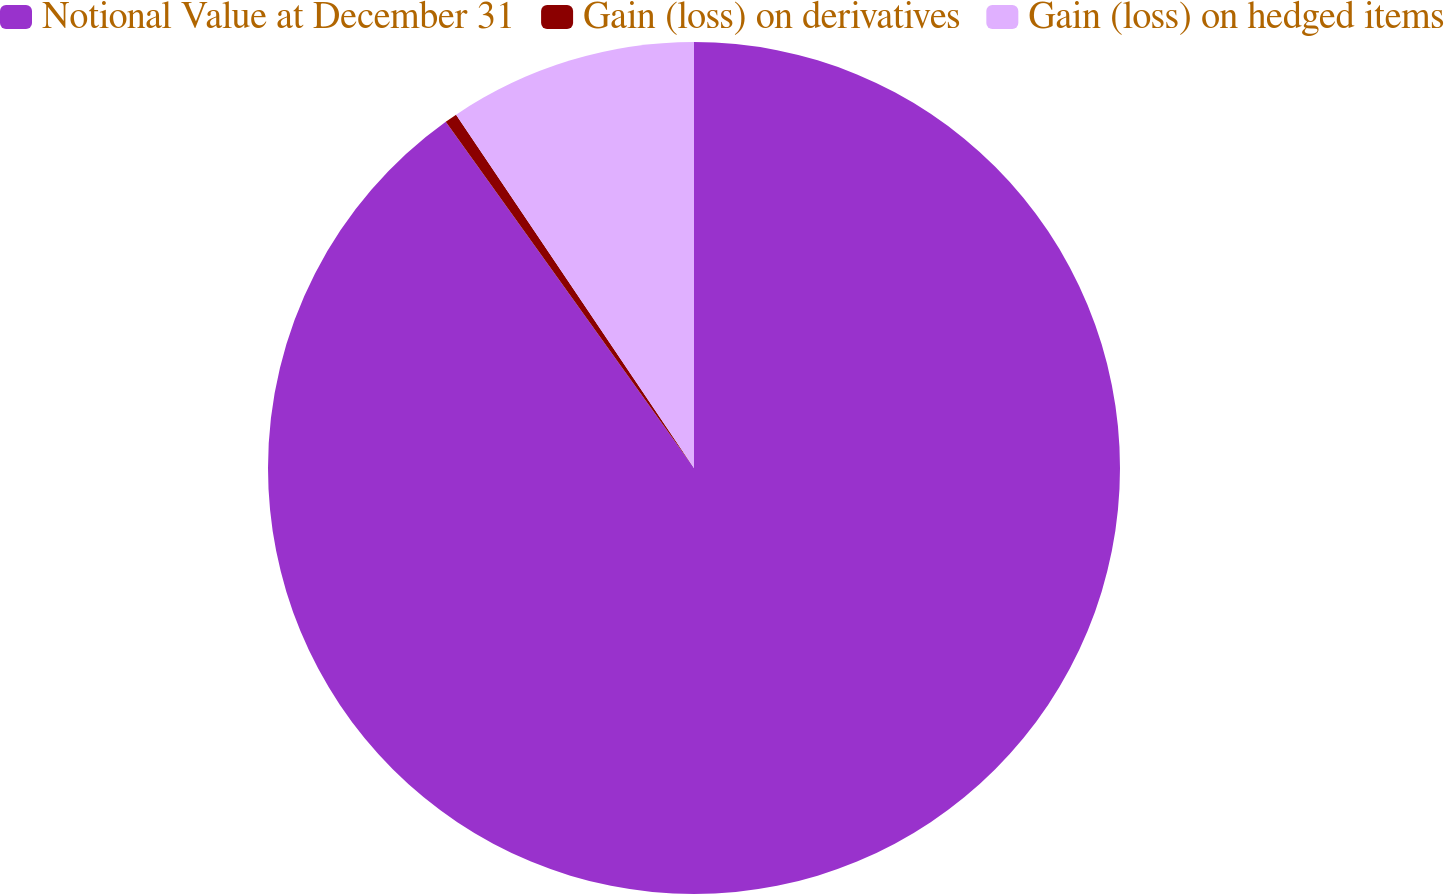<chart> <loc_0><loc_0><loc_500><loc_500><pie_chart><fcel>Notional Value at December 31<fcel>Gain (loss) on derivatives<fcel>Gain (loss) on hedged items<nl><fcel>90.09%<fcel>0.47%<fcel>9.43%<nl></chart> 